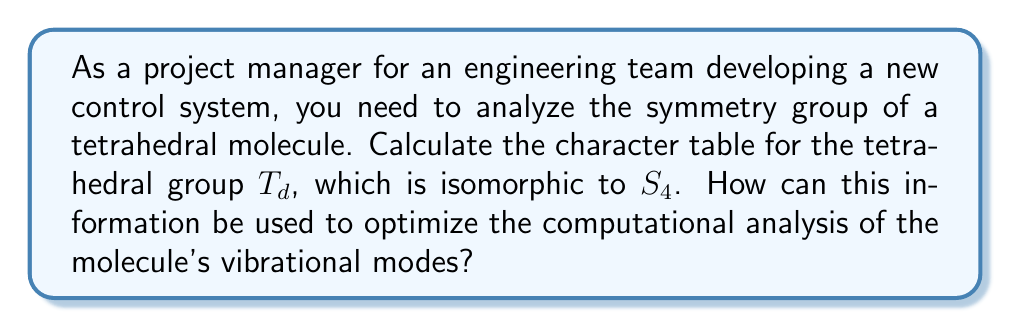Could you help me with this problem? To calculate the character table for the tetrahedral group $T_d$, we'll follow these steps:

1. Identify the conjugacy classes of $T_d$:
   - $C_1$: Identity (1 element)
   - $C_2$: Rotations by $\pi$ (3 elements)
   - $C_3$: Rotations by $\frac{2\pi}{3}$ (8 elements)
   - $C_2'$: Rotations by $\pi$ through edges (6 elements)
   - $S_4$: Improper rotations (6 elements)

2. Determine the number of irreducible representations:
   There are 5 conjugacy classes, so there will be 5 irreducible representations.

3. Use the orthogonality theorem to find the dimensions of the irreducible representations:
   $1^2 + 1^2 + 1^2 + 1^2 + 3^2 = 24$ (order of $T_d$)

4. Label the representations:
   $A_1$, $A_2$, $E$, $T_1$, and $T_2$

5. Fill in the character table:

   $$\begin{array}{c|ccccc}
   T_d & E & 8C_3 & 3C_2 & 6C_2' & 6S_4 \\
   \hline
   A_1 & 1 & 1 & 1 & 1 & 1 \\
   A_2 & 1 & 1 & 1 & -1 & -1 \\
   E & 2 & -1 & 2 & 0 & 0 \\
   T_1 & 3 & 0 & -1 & -1 & 1 \\
   T_2 & 3 & 0 & -1 & 1 & -1
   \end{array}$$

6. Verify the orthogonality relations and row/column sums.

To optimize the computational analysis of the molecule's vibrational modes:

a) Use the character table to determine which vibrational modes are IR or Raman active.
b) Exploit symmetry to reduce the number of calculations needed for force constants.
c) Decompose the vibrational representation into irreducible representations to predict the number of modes of each symmetry type.
d) Use group theory to block-diagonalize the Hessian matrix, simplifying eigenvalue calculations.

This approach can significantly reduce computational complexity and improve efficiency in analyzing the molecule's vibrational properties.
Answer: Character table of $T_d$ group with 5 irreducible representations; Use to simplify vibrational mode analysis through symmetry-based matrix block-diagonalization and mode classification. 